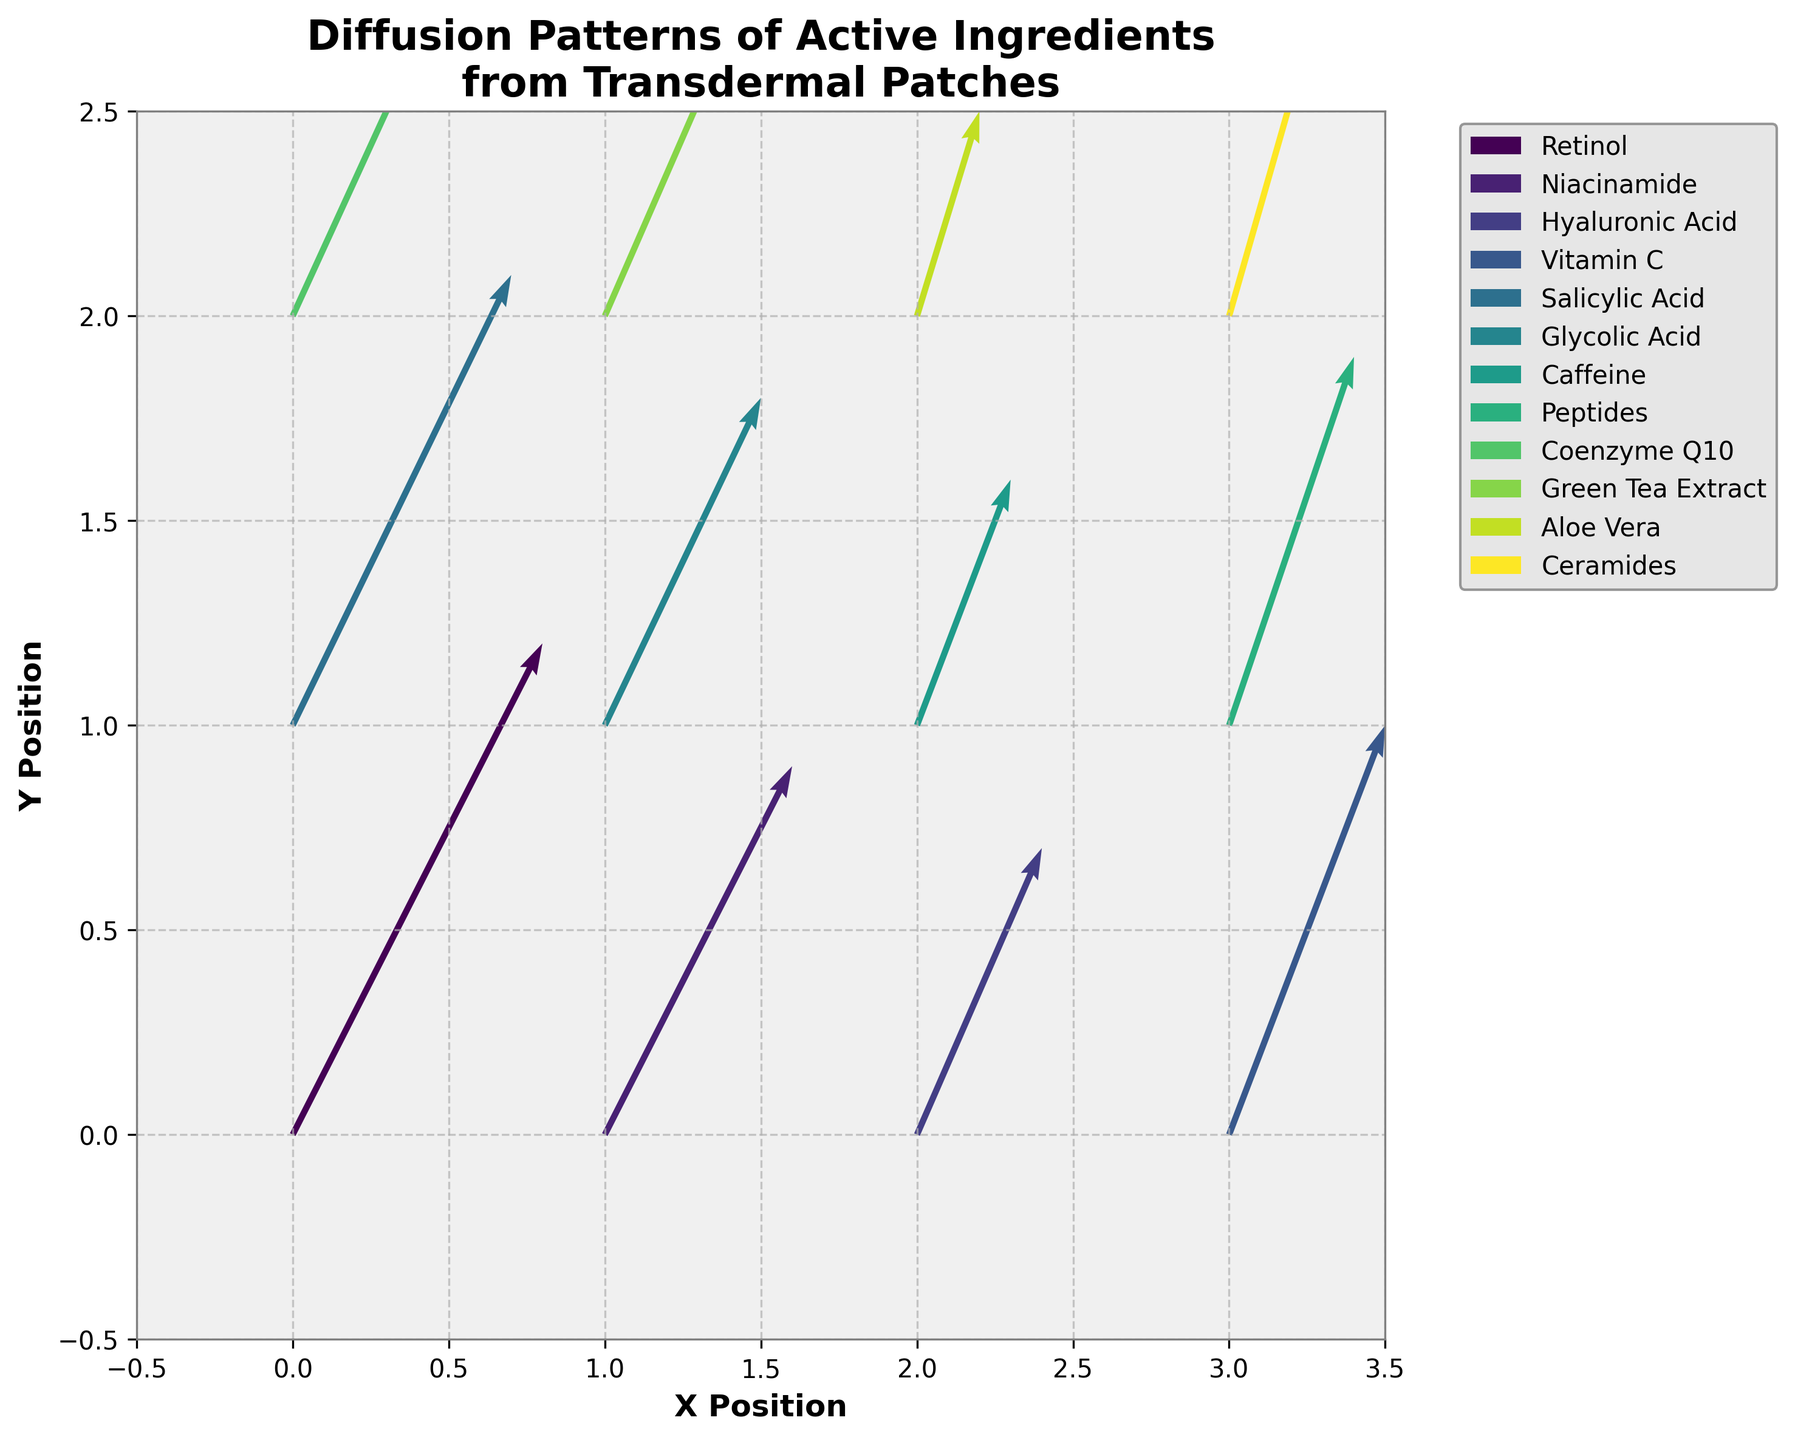What is the title of the plot? The title of the plot is written at the top center of the figure. It helps to indicate what the plot is about.
Answer: Diffusion Patterns of Active Ingredients from Transdermal Patches What are the labels on the x and y axes? The labels on the axes indicate what each axis represents in the plot. They are typically found along the sides of the figure next to the axis tick marks.
Answer: X Position, Y Position Which ingredient has the highest magnitude of diffusion vectors directly from the origin (0,0)? To determine this, look at the length of the arrows originating from the (0,0) position.
Answer: Retinol Compare the diffusion vectors of Niacinamide and Glycolic Acid. Which one has a larger magnitude? Compute the magnitude of each vector using the formula \(\sqrt{u^2 + v^2}\). For Niacinamide, the vector is (0.6, 0.9), and for Glycolic Acid, it’s (0.5, 0.8).
Answer: Niacinamide Which ingredients show a directional movement primarily in the y-direction? Check the vectors where the y-component (v) is significantly larger than the x-component (u).
Answer: Retinol, Salicylic Acid, Coenzyme Q10 What is the color scheme of the arrows and how does it help in distinguishing different ingredients? Assess the colors of the arrows in the plot which use a gradient or different shades to differentiate between various ingredients.
Answer: Viridis color scheme What is the combined directional change vector (resultant vector) for the arrows at position (0,1) and (0,2)? Sum the corresponding u and v components of the vectors at (0,1) and (0,2) locations. For Salicylic Acid (0.7, 1.1) and Coenzyme Q10 (0.6, 1.0), the resultant vector is (0.7+0.6, 1.1+1.0).
Answer: (1.3, 2.1) Which ingredient positioned at y = 1 has the smallest magnitude of the diffusion vector? Compute the magnitudes of the vectors at y = 1 and find the smallest. At y = 1, we have Salicylic Acid, Glycolic Acid, Caffeine, and Peptides. Calculate using \(\sqrt{u^2 + v^2}\).
Answer: Caffeine What is the range of x and y coordinates shown in the plot? The range shows the span of the plot along the x and y dimensions, visible through the axis limits on the figure.
Answer: x: -0.5 to 3.5, y: -0.5 to 2.5 How do the background color and grid lines contribute to the readability of the plot? Examine how the background color and grid lines enhance the differentiation between different elements and make the plot easier to interpret.
Answer: The background color (#f0f0f0) and grid lines (dashed, lightened) enhance readability 